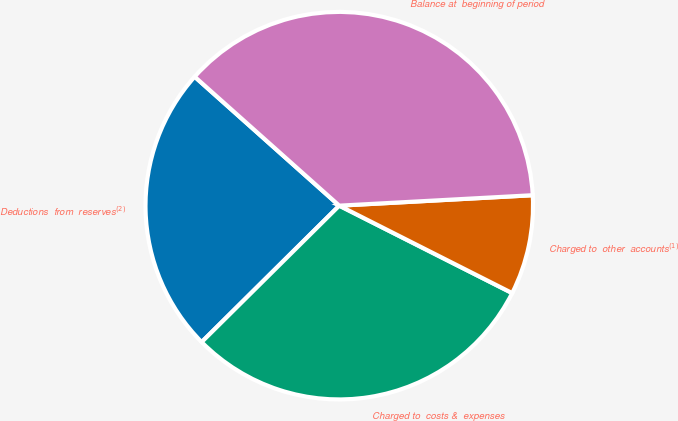Convert chart. <chart><loc_0><loc_0><loc_500><loc_500><pie_chart><fcel>Deductions  from  reserves$^{(2)}$<fcel>Charged to  costs &  expenses<fcel>Charged to  other  accounts$^{(1)}$<fcel>Balance at  beginning of period<nl><fcel>24.02%<fcel>30.12%<fcel>8.31%<fcel>37.55%<nl></chart> 